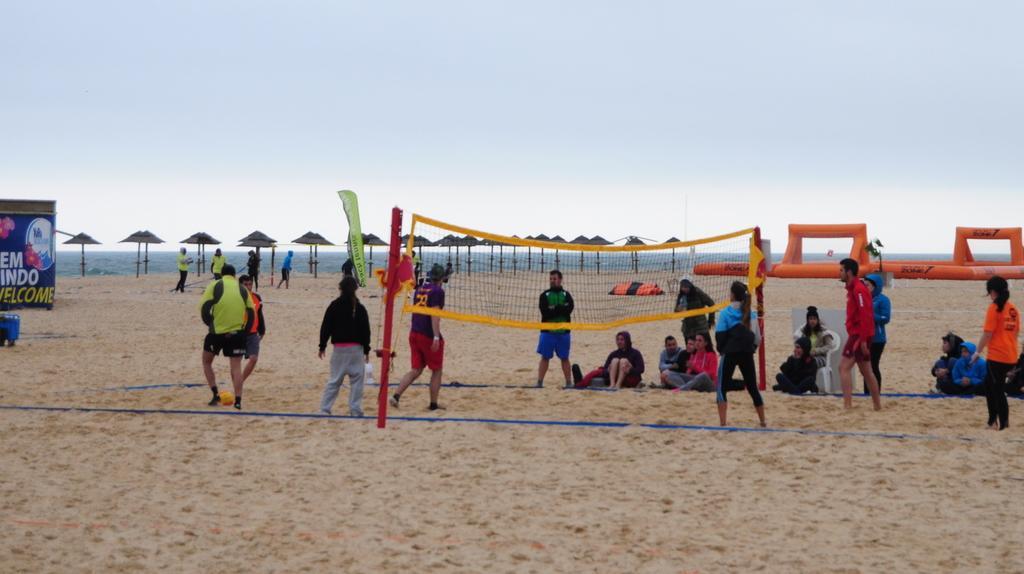How would you summarize this image in a sentence or two? Here few people are playing the games. This is the net, at the top it's a sky. 